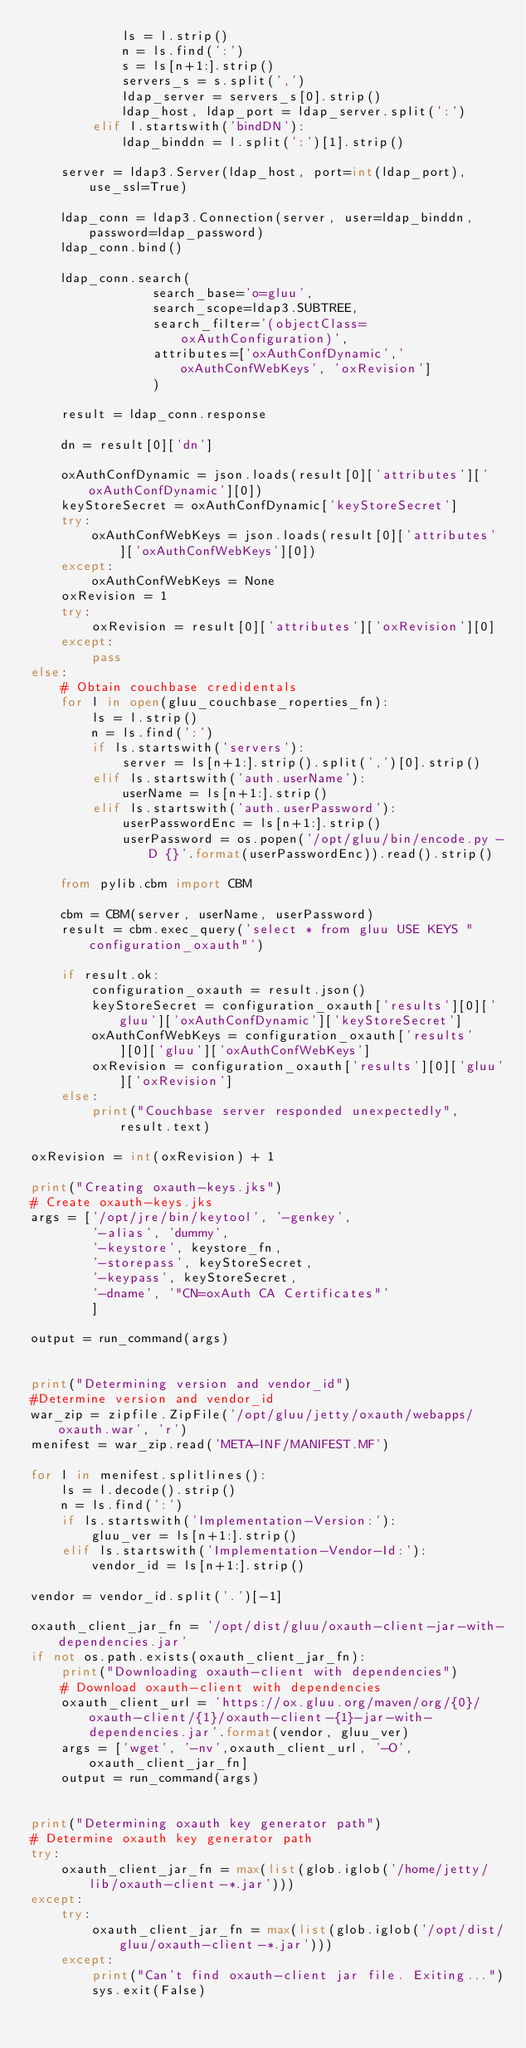<code> <loc_0><loc_0><loc_500><loc_500><_Python_>            ls = l.strip()
            n = ls.find(':')
            s = ls[n+1:].strip()
            servers_s = s.split(',')
            ldap_server = servers_s[0].strip()
            ldap_host, ldap_port = ldap_server.split(':')
        elif l.startswith('bindDN'):
            ldap_binddn = l.split(':')[1].strip()

    server = ldap3.Server(ldap_host, port=int(ldap_port), use_ssl=True)
    
    ldap_conn = ldap3.Connection(server, user=ldap_binddn, password=ldap_password)
    ldap_conn.bind()

    ldap_conn.search(
                search_base='o=gluu', 
                search_scope=ldap3.SUBTREE, 
                search_filter='(objectClass=oxAuthConfiguration)', 
                attributes=['oxAuthConfDynamic','oxAuthConfWebKeys', 'oxRevision']
                )

    result = ldap_conn.response

    dn = result[0]['dn']

    oxAuthConfDynamic = json.loads(result[0]['attributes']['oxAuthConfDynamic'][0])
    keyStoreSecret = oxAuthConfDynamic['keyStoreSecret']
    try:
        oxAuthConfWebKeys = json.loads(result[0]['attributes']['oxAuthConfWebKeys'][0])
    except:
        oxAuthConfWebKeys = None
    oxRevision = 1
    try:
        oxRevision = result[0]['attributes']['oxRevision'][0]
    except:
        pass
else:
    # Obtain couchbase credidentals
    for l in open(gluu_couchbase_roperties_fn):
        ls = l.strip()
        n = ls.find(':')
        if ls.startswith('servers'):
            server = ls[n+1:].strip().split(',')[0].strip()
        elif ls.startswith('auth.userName'):
            userName = ls[n+1:].strip()
        elif ls.startswith('auth.userPassword'):
            userPasswordEnc = ls[n+1:].strip()
            userPassword = os.popen('/opt/gluu/bin/encode.py -D {}'.format(userPasswordEnc)).read().strip()

    from pylib.cbm import CBM

    cbm = CBM(server, userName, userPassword)
    result = cbm.exec_query('select * from gluu USE KEYS "configuration_oxauth"')

    if result.ok:
        configuration_oxauth = result.json()
        keyStoreSecret = configuration_oxauth['results'][0]['gluu']['oxAuthConfDynamic']['keyStoreSecret']
        oxAuthConfWebKeys = configuration_oxauth['results'][0]['gluu']['oxAuthConfWebKeys']
        oxRevision = configuration_oxauth['results'][0]['gluu']['oxRevision']
    else:
        print("Couchbase server responded unexpectedly", result.text)

oxRevision = int(oxRevision) + 1

print("Creating oxauth-keys.jks")
# Create oxauth-keys.jks
args = ['/opt/jre/bin/keytool', '-genkey',
        '-alias', 'dummy',
        '-keystore', keystore_fn,
        '-storepass', keyStoreSecret,
        '-keypass', keyStoreSecret,
        '-dname', '"CN=oxAuth CA Certificates"'
        ]

output = run_command(args)


print("Determining version and vendor_id")
#Determine version and vendor_id
war_zip = zipfile.ZipFile('/opt/gluu/jetty/oxauth/webapps/oxauth.war', 'r')
menifest = war_zip.read('META-INF/MANIFEST.MF')

for l in menifest.splitlines():
    ls = l.decode().strip()
    n = ls.find(':')
    if ls.startswith('Implementation-Version:'):
        gluu_ver = ls[n+1:].strip()
    elif ls.startswith('Implementation-Vendor-Id:'):
        vendor_id = ls[n+1:].strip()

vendor = vendor_id.split('.')[-1]

oxauth_client_jar_fn = '/opt/dist/gluu/oxauth-client-jar-with-dependencies.jar'
if not os.path.exists(oxauth_client_jar_fn):
    print("Downloading oxauth-client with dependencies")
    # Download oxauth-client with dependencies
    oxauth_client_url = 'https://ox.gluu.org/maven/org/{0}/oxauth-client/{1}/oxauth-client-{1}-jar-with-dependencies.jar'.format(vendor, gluu_ver)
    args = ['wget', '-nv',oxauth_client_url, '-O', oxauth_client_jar_fn]
    output = run_command(args)


print("Determining oxauth key generator path")
# Determine oxauth key generator path
try:
    oxauth_client_jar_fn = max(list(glob.iglob('/home/jetty/lib/oxauth-client-*.jar')))
except:
    try:
        oxauth_client_jar_fn = max(list(glob.iglob('/opt/dist/gluu/oxauth-client-*.jar')))
    except:
        print("Can't find oxauth-client jar file. Exiting...")
        sys.exit(False)

</code> 